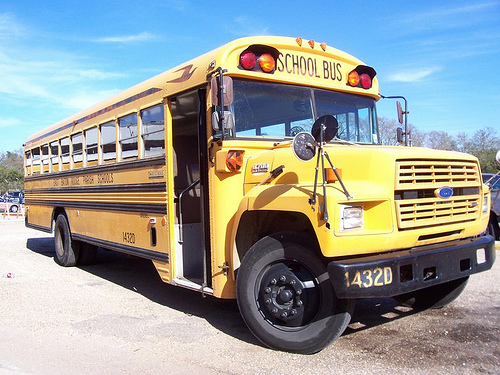What safety features can you identify on this school bus? Several safety features are evident on this school bus including the bright yellow paint, which is highly visible even in low light. The large, retractable stop sign emblazoned with the word 'STOP' is used when children are boarding or disembarking to alert other drivers. Extensive mirror systems ensure the driver has a broad field of vision around the bus. Flashing red lights above the windshield and at the rear alert other road users when the bus is stopping. The sturdy construction with reinforced sides provides enhanced protection for passengers inside. 